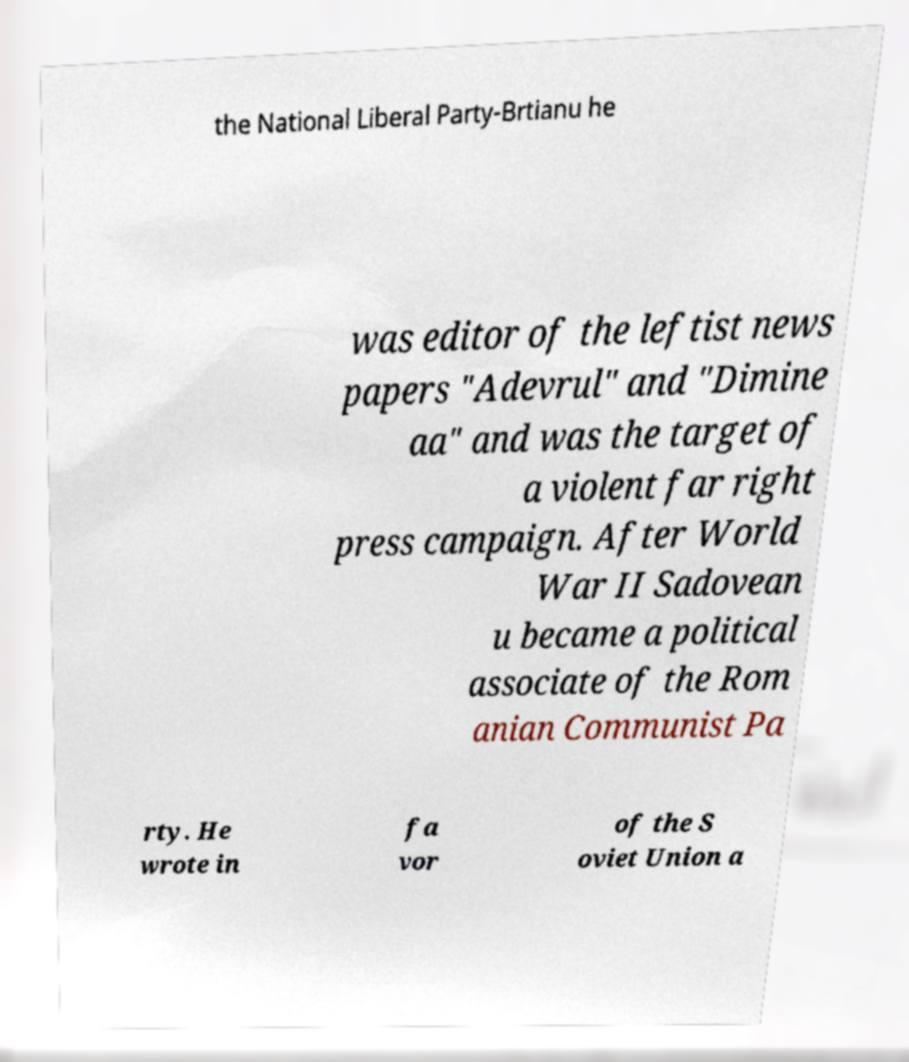Could you assist in decoding the text presented in this image and type it out clearly? the National Liberal Party-Brtianu he was editor of the leftist news papers "Adevrul" and "Dimine aa" and was the target of a violent far right press campaign. After World War II Sadovean u became a political associate of the Rom anian Communist Pa rty. He wrote in fa vor of the S oviet Union a 